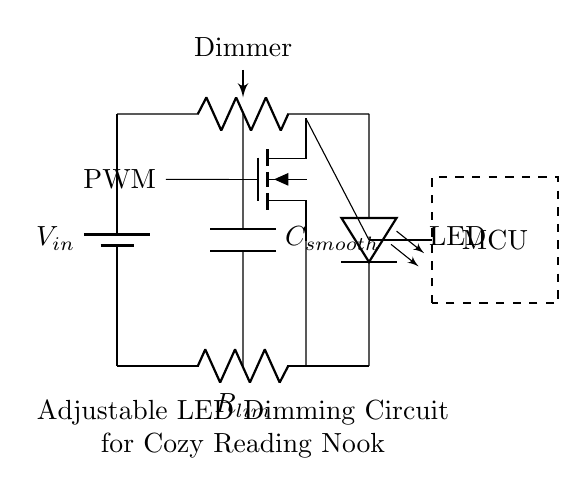What type of circuit component is used for dimming? A potentiometer is used in the circuit to adjust the brightness of the LED by varying resistance.
Answer: Potentiometer What controls the LED brightness? The microcontroller generates a PWM signal that is sent to the MOSFET, adjusting the power delivered to the LED.
Answer: PWM What does the capacitor do in this circuit? The capacitor smooths out the voltage fluctuations coming from the PWM signal, providing more stable power to the LED.
Answer: Smoothing How many main components are in this circuit? The circuit contains a battery, potentiometer, LED, resistor, capacitor, MOSFET, and microcontroller, totaling six main components.
Answer: Six What is the purpose of the resistor in this circuit? The resistor limits the current flowing through the LED, preventing it from burning out due to excessive current.
Answer: Current limiting What is the input voltage denoted as? The input voltage in the circuit is represented by V in, which refers to the supply voltage coming to the circuit.
Answer: V in What type of device is represented by the dashed rectangle? The dashed rectangle represents a microcontroller, which is responsible for controlling the dimming function through PWM signals.
Answer: Microcontroller 